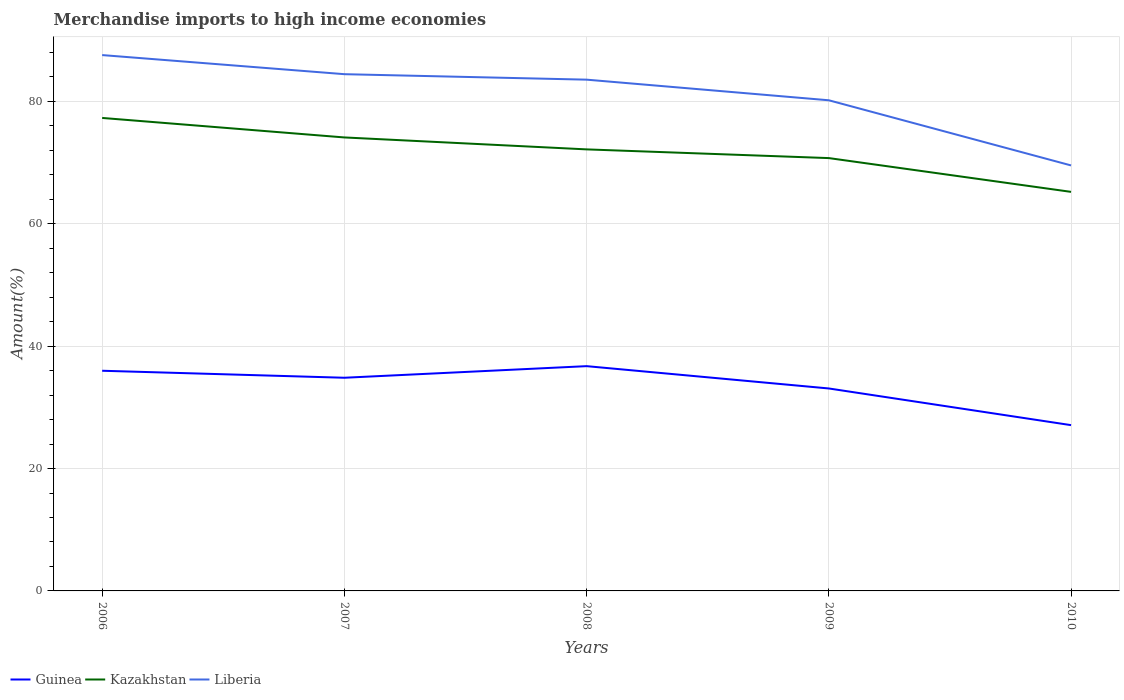How many different coloured lines are there?
Keep it short and to the point. 3. Does the line corresponding to Guinea intersect with the line corresponding to Liberia?
Your answer should be compact. No. Across all years, what is the maximum percentage of amount earned from merchandise imports in Liberia?
Your answer should be compact. 69.54. In which year was the percentage of amount earned from merchandise imports in Kazakhstan maximum?
Offer a terse response. 2010. What is the total percentage of amount earned from merchandise imports in Guinea in the graph?
Give a very brief answer. -1.9. What is the difference between the highest and the second highest percentage of amount earned from merchandise imports in Kazakhstan?
Give a very brief answer. 12.08. What is the difference between the highest and the lowest percentage of amount earned from merchandise imports in Guinea?
Offer a terse response. 3. Is the percentage of amount earned from merchandise imports in Liberia strictly greater than the percentage of amount earned from merchandise imports in Kazakhstan over the years?
Offer a very short reply. No. Are the values on the major ticks of Y-axis written in scientific E-notation?
Offer a terse response. No. Does the graph contain grids?
Your answer should be very brief. Yes. Where does the legend appear in the graph?
Provide a short and direct response. Bottom left. How many legend labels are there?
Ensure brevity in your answer.  3. How are the legend labels stacked?
Keep it short and to the point. Horizontal. What is the title of the graph?
Provide a succinct answer. Merchandise imports to high income economies. What is the label or title of the Y-axis?
Give a very brief answer. Amount(%). What is the Amount(%) in Guinea in 2006?
Keep it short and to the point. 35.98. What is the Amount(%) in Kazakhstan in 2006?
Your answer should be compact. 77.3. What is the Amount(%) in Liberia in 2006?
Give a very brief answer. 87.58. What is the Amount(%) of Guinea in 2007?
Provide a short and direct response. 34.84. What is the Amount(%) in Kazakhstan in 2007?
Provide a short and direct response. 74.11. What is the Amount(%) in Liberia in 2007?
Keep it short and to the point. 84.45. What is the Amount(%) of Guinea in 2008?
Give a very brief answer. 36.74. What is the Amount(%) in Kazakhstan in 2008?
Your answer should be compact. 72.16. What is the Amount(%) of Liberia in 2008?
Your answer should be compact. 83.56. What is the Amount(%) of Guinea in 2009?
Offer a terse response. 33.09. What is the Amount(%) of Kazakhstan in 2009?
Your answer should be compact. 70.74. What is the Amount(%) of Liberia in 2009?
Make the answer very short. 80.19. What is the Amount(%) of Guinea in 2010?
Give a very brief answer. 27.09. What is the Amount(%) in Kazakhstan in 2010?
Your response must be concise. 65.22. What is the Amount(%) in Liberia in 2010?
Provide a succinct answer. 69.54. Across all years, what is the maximum Amount(%) of Guinea?
Make the answer very short. 36.74. Across all years, what is the maximum Amount(%) in Kazakhstan?
Make the answer very short. 77.3. Across all years, what is the maximum Amount(%) of Liberia?
Make the answer very short. 87.58. Across all years, what is the minimum Amount(%) in Guinea?
Ensure brevity in your answer.  27.09. Across all years, what is the minimum Amount(%) of Kazakhstan?
Provide a short and direct response. 65.22. Across all years, what is the minimum Amount(%) of Liberia?
Offer a very short reply. 69.54. What is the total Amount(%) of Guinea in the graph?
Offer a very short reply. 167.74. What is the total Amount(%) of Kazakhstan in the graph?
Offer a terse response. 359.54. What is the total Amount(%) in Liberia in the graph?
Your answer should be very brief. 405.31. What is the difference between the Amount(%) in Guinea in 2006 and that in 2007?
Provide a succinct answer. 1.14. What is the difference between the Amount(%) in Kazakhstan in 2006 and that in 2007?
Provide a succinct answer. 3.19. What is the difference between the Amount(%) of Liberia in 2006 and that in 2007?
Provide a short and direct response. 3.12. What is the difference between the Amount(%) of Guinea in 2006 and that in 2008?
Provide a succinct answer. -0.75. What is the difference between the Amount(%) in Kazakhstan in 2006 and that in 2008?
Your answer should be very brief. 5.14. What is the difference between the Amount(%) of Liberia in 2006 and that in 2008?
Ensure brevity in your answer.  4.02. What is the difference between the Amount(%) in Guinea in 2006 and that in 2009?
Offer a terse response. 2.9. What is the difference between the Amount(%) of Kazakhstan in 2006 and that in 2009?
Offer a very short reply. 6.56. What is the difference between the Amount(%) in Liberia in 2006 and that in 2009?
Make the answer very short. 7.39. What is the difference between the Amount(%) in Guinea in 2006 and that in 2010?
Offer a terse response. 8.89. What is the difference between the Amount(%) in Kazakhstan in 2006 and that in 2010?
Provide a succinct answer. 12.08. What is the difference between the Amount(%) of Liberia in 2006 and that in 2010?
Your answer should be compact. 18.04. What is the difference between the Amount(%) of Guinea in 2007 and that in 2008?
Give a very brief answer. -1.9. What is the difference between the Amount(%) in Kazakhstan in 2007 and that in 2008?
Give a very brief answer. 1.95. What is the difference between the Amount(%) in Liberia in 2007 and that in 2008?
Make the answer very short. 0.9. What is the difference between the Amount(%) of Guinea in 2007 and that in 2009?
Offer a terse response. 1.75. What is the difference between the Amount(%) of Kazakhstan in 2007 and that in 2009?
Keep it short and to the point. 3.37. What is the difference between the Amount(%) in Liberia in 2007 and that in 2009?
Your response must be concise. 4.27. What is the difference between the Amount(%) of Guinea in 2007 and that in 2010?
Offer a terse response. 7.74. What is the difference between the Amount(%) of Kazakhstan in 2007 and that in 2010?
Offer a very short reply. 8.9. What is the difference between the Amount(%) of Liberia in 2007 and that in 2010?
Your response must be concise. 14.91. What is the difference between the Amount(%) in Guinea in 2008 and that in 2009?
Your response must be concise. 3.65. What is the difference between the Amount(%) of Kazakhstan in 2008 and that in 2009?
Make the answer very short. 1.42. What is the difference between the Amount(%) in Liberia in 2008 and that in 2009?
Your answer should be very brief. 3.37. What is the difference between the Amount(%) of Guinea in 2008 and that in 2010?
Your response must be concise. 9.64. What is the difference between the Amount(%) of Kazakhstan in 2008 and that in 2010?
Your response must be concise. 6.94. What is the difference between the Amount(%) in Liberia in 2008 and that in 2010?
Ensure brevity in your answer.  14.02. What is the difference between the Amount(%) in Guinea in 2009 and that in 2010?
Keep it short and to the point. 5.99. What is the difference between the Amount(%) in Kazakhstan in 2009 and that in 2010?
Offer a very short reply. 5.52. What is the difference between the Amount(%) in Liberia in 2009 and that in 2010?
Your answer should be compact. 10.65. What is the difference between the Amount(%) in Guinea in 2006 and the Amount(%) in Kazakhstan in 2007?
Your response must be concise. -38.13. What is the difference between the Amount(%) of Guinea in 2006 and the Amount(%) of Liberia in 2007?
Ensure brevity in your answer.  -48.47. What is the difference between the Amount(%) in Kazakhstan in 2006 and the Amount(%) in Liberia in 2007?
Provide a short and direct response. -7.15. What is the difference between the Amount(%) of Guinea in 2006 and the Amount(%) of Kazakhstan in 2008?
Provide a short and direct response. -36.18. What is the difference between the Amount(%) in Guinea in 2006 and the Amount(%) in Liberia in 2008?
Offer a very short reply. -47.57. What is the difference between the Amount(%) of Kazakhstan in 2006 and the Amount(%) of Liberia in 2008?
Your answer should be very brief. -6.26. What is the difference between the Amount(%) in Guinea in 2006 and the Amount(%) in Kazakhstan in 2009?
Your response must be concise. -34.76. What is the difference between the Amount(%) in Guinea in 2006 and the Amount(%) in Liberia in 2009?
Offer a very short reply. -44.2. What is the difference between the Amount(%) in Kazakhstan in 2006 and the Amount(%) in Liberia in 2009?
Offer a very short reply. -2.89. What is the difference between the Amount(%) of Guinea in 2006 and the Amount(%) of Kazakhstan in 2010?
Provide a succinct answer. -29.23. What is the difference between the Amount(%) of Guinea in 2006 and the Amount(%) of Liberia in 2010?
Provide a succinct answer. -33.56. What is the difference between the Amount(%) in Kazakhstan in 2006 and the Amount(%) in Liberia in 2010?
Make the answer very short. 7.76. What is the difference between the Amount(%) in Guinea in 2007 and the Amount(%) in Kazakhstan in 2008?
Offer a very short reply. -37.32. What is the difference between the Amount(%) of Guinea in 2007 and the Amount(%) of Liberia in 2008?
Keep it short and to the point. -48.72. What is the difference between the Amount(%) in Kazakhstan in 2007 and the Amount(%) in Liberia in 2008?
Provide a succinct answer. -9.44. What is the difference between the Amount(%) of Guinea in 2007 and the Amount(%) of Kazakhstan in 2009?
Keep it short and to the point. -35.9. What is the difference between the Amount(%) in Guinea in 2007 and the Amount(%) in Liberia in 2009?
Give a very brief answer. -45.35. What is the difference between the Amount(%) in Kazakhstan in 2007 and the Amount(%) in Liberia in 2009?
Provide a succinct answer. -6.07. What is the difference between the Amount(%) in Guinea in 2007 and the Amount(%) in Kazakhstan in 2010?
Ensure brevity in your answer.  -30.38. What is the difference between the Amount(%) in Guinea in 2007 and the Amount(%) in Liberia in 2010?
Offer a terse response. -34.7. What is the difference between the Amount(%) of Kazakhstan in 2007 and the Amount(%) of Liberia in 2010?
Your response must be concise. 4.57. What is the difference between the Amount(%) in Guinea in 2008 and the Amount(%) in Kazakhstan in 2009?
Your response must be concise. -34. What is the difference between the Amount(%) in Guinea in 2008 and the Amount(%) in Liberia in 2009?
Your response must be concise. -43.45. What is the difference between the Amount(%) of Kazakhstan in 2008 and the Amount(%) of Liberia in 2009?
Ensure brevity in your answer.  -8.02. What is the difference between the Amount(%) of Guinea in 2008 and the Amount(%) of Kazakhstan in 2010?
Provide a short and direct response. -28.48. What is the difference between the Amount(%) in Guinea in 2008 and the Amount(%) in Liberia in 2010?
Keep it short and to the point. -32.8. What is the difference between the Amount(%) in Kazakhstan in 2008 and the Amount(%) in Liberia in 2010?
Your response must be concise. 2.62. What is the difference between the Amount(%) of Guinea in 2009 and the Amount(%) of Kazakhstan in 2010?
Your answer should be compact. -32.13. What is the difference between the Amount(%) of Guinea in 2009 and the Amount(%) of Liberia in 2010?
Your response must be concise. -36.45. What is the difference between the Amount(%) of Kazakhstan in 2009 and the Amount(%) of Liberia in 2010?
Give a very brief answer. 1.2. What is the average Amount(%) of Guinea per year?
Give a very brief answer. 33.55. What is the average Amount(%) in Kazakhstan per year?
Provide a succinct answer. 71.91. What is the average Amount(%) of Liberia per year?
Make the answer very short. 81.06. In the year 2006, what is the difference between the Amount(%) of Guinea and Amount(%) of Kazakhstan?
Make the answer very short. -41.32. In the year 2006, what is the difference between the Amount(%) of Guinea and Amount(%) of Liberia?
Keep it short and to the point. -51.59. In the year 2006, what is the difference between the Amount(%) in Kazakhstan and Amount(%) in Liberia?
Your response must be concise. -10.27. In the year 2007, what is the difference between the Amount(%) of Guinea and Amount(%) of Kazakhstan?
Provide a short and direct response. -39.27. In the year 2007, what is the difference between the Amount(%) in Guinea and Amount(%) in Liberia?
Make the answer very short. -49.61. In the year 2007, what is the difference between the Amount(%) of Kazakhstan and Amount(%) of Liberia?
Your answer should be compact. -10.34. In the year 2008, what is the difference between the Amount(%) of Guinea and Amount(%) of Kazakhstan?
Keep it short and to the point. -35.43. In the year 2008, what is the difference between the Amount(%) in Guinea and Amount(%) in Liberia?
Offer a very short reply. -46.82. In the year 2008, what is the difference between the Amount(%) in Kazakhstan and Amount(%) in Liberia?
Your answer should be very brief. -11.4. In the year 2009, what is the difference between the Amount(%) in Guinea and Amount(%) in Kazakhstan?
Offer a terse response. -37.65. In the year 2009, what is the difference between the Amount(%) in Guinea and Amount(%) in Liberia?
Give a very brief answer. -47.1. In the year 2009, what is the difference between the Amount(%) of Kazakhstan and Amount(%) of Liberia?
Give a very brief answer. -9.45. In the year 2010, what is the difference between the Amount(%) in Guinea and Amount(%) in Kazakhstan?
Make the answer very short. -38.12. In the year 2010, what is the difference between the Amount(%) in Guinea and Amount(%) in Liberia?
Provide a succinct answer. -42.45. In the year 2010, what is the difference between the Amount(%) in Kazakhstan and Amount(%) in Liberia?
Your answer should be very brief. -4.32. What is the ratio of the Amount(%) in Guinea in 2006 to that in 2007?
Ensure brevity in your answer.  1.03. What is the ratio of the Amount(%) in Kazakhstan in 2006 to that in 2007?
Your answer should be very brief. 1.04. What is the ratio of the Amount(%) in Liberia in 2006 to that in 2007?
Keep it short and to the point. 1.04. What is the ratio of the Amount(%) of Guinea in 2006 to that in 2008?
Your answer should be compact. 0.98. What is the ratio of the Amount(%) in Kazakhstan in 2006 to that in 2008?
Your answer should be very brief. 1.07. What is the ratio of the Amount(%) in Liberia in 2006 to that in 2008?
Ensure brevity in your answer.  1.05. What is the ratio of the Amount(%) of Guinea in 2006 to that in 2009?
Make the answer very short. 1.09. What is the ratio of the Amount(%) of Kazakhstan in 2006 to that in 2009?
Keep it short and to the point. 1.09. What is the ratio of the Amount(%) in Liberia in 2006 to that in 2009?
Provide a short and direct response. 1.09. What is the ratio of the Amount(%) of Guinea in 2006 to that in 2010?
Give a very brief answer. 1.33. What is the ratio of the Amount(%) in Kazakhstan in 2006 to that in 2010?
Your response must be concise. 1.19. What is the ratio of the Amount(%) in Liberia in 2006 to that in 2010?
Offer a very short reply. 1.26. What is the ratio of the Amount(%) of Guinea in 2007 to that in 2008?
Offer a very short reply. 0.95. What is the ratio of the Amount(%) in Liberia in 2007 to that in 2008?
Ensure brevity in your answer.  1.01. What is the ratio of the Amount(%) in Guinea in 2007 to that in 2009?
Provide a succinct answer. 1.05. What is the ratio of the Amount(%) in Kazakhstan in 2007 to that in 2009?
Your answer should be compact. 1.05. What is the ratio of the Amount(%) of Liberia in 2007 to that in 2009?
Your answer should be very brief. 1.05. What is the ratio of the Amount(%) of Guinea in 2007 to that in 2010?
Your answer should be very brief. 1.29. What is the ratio of the Amount(%) in Kazakhstan in 2007 to that in 2010?
Provide a succinct answer. 1.14. What is the ratio of the Amount(%) in Liberia in 2007 to that in 2010?
Ensure brevity in your answer.  1.21. What is the ratio of the Amount(%) in Guinea in 2008 to that in 2009?
Offer a very short reply. 1.11. What is the ratio of the Amount(%) of Kazakhstan in 2008 to that in 2009?
Your response must be concise. 1.02. What is the ratio of the Amount(%) of Liberia in 2008 to that in 2009?
Your answer should be very brief. 1.04. What is the ratio of the Amount(%) of Guinea in 2008 to that in 2010?
Ensure brevity in your answer.  1.36. What is the ratio of the Amount(%) of Kazakhstan in 2008 to that in 2010?
Give a very brief answer. 1.11. What is the ratio of the Amount(%) of Liberia in 2008 to that in 2010?
Offer a terse response. 1.2. What is the ratio of the Amount(%) in Guinea in 2009 to that in 2010?
Keep it short and to the point. 1.22. What is the ratio of the Amount(%) in Kazakhstan in 2009 to that in 2010?
Your answer should be very brief. 1.08. What is the ratio of the Amount(%) in Liberia in 2009 to that in 2010?
Keep it short and to the point. 1.15. What is the difference between the highest and the second highest Amount(%) of Guinea?
Ensure brevity in your answer.  0.75. What is the difference between the highest and the second highest Amount(%) in Kazakhstan?
Your response must be concise. 3.19. What is the difference between the highest and the second highest Amount(%) of Liberia?
Offer a terse response. 3.12. What is the difference between the highest and the lowest Amount(%) of Guinea?
Offer a very short reply. 9.64. What is the difference between the highest and the lowest Amount(%) in Kazakhstan?
Your answer should be compact. 12.08. What is the difference between the highest and the lowest Amount(%) in Liberia?
Give a very brief answer. 18.04. 